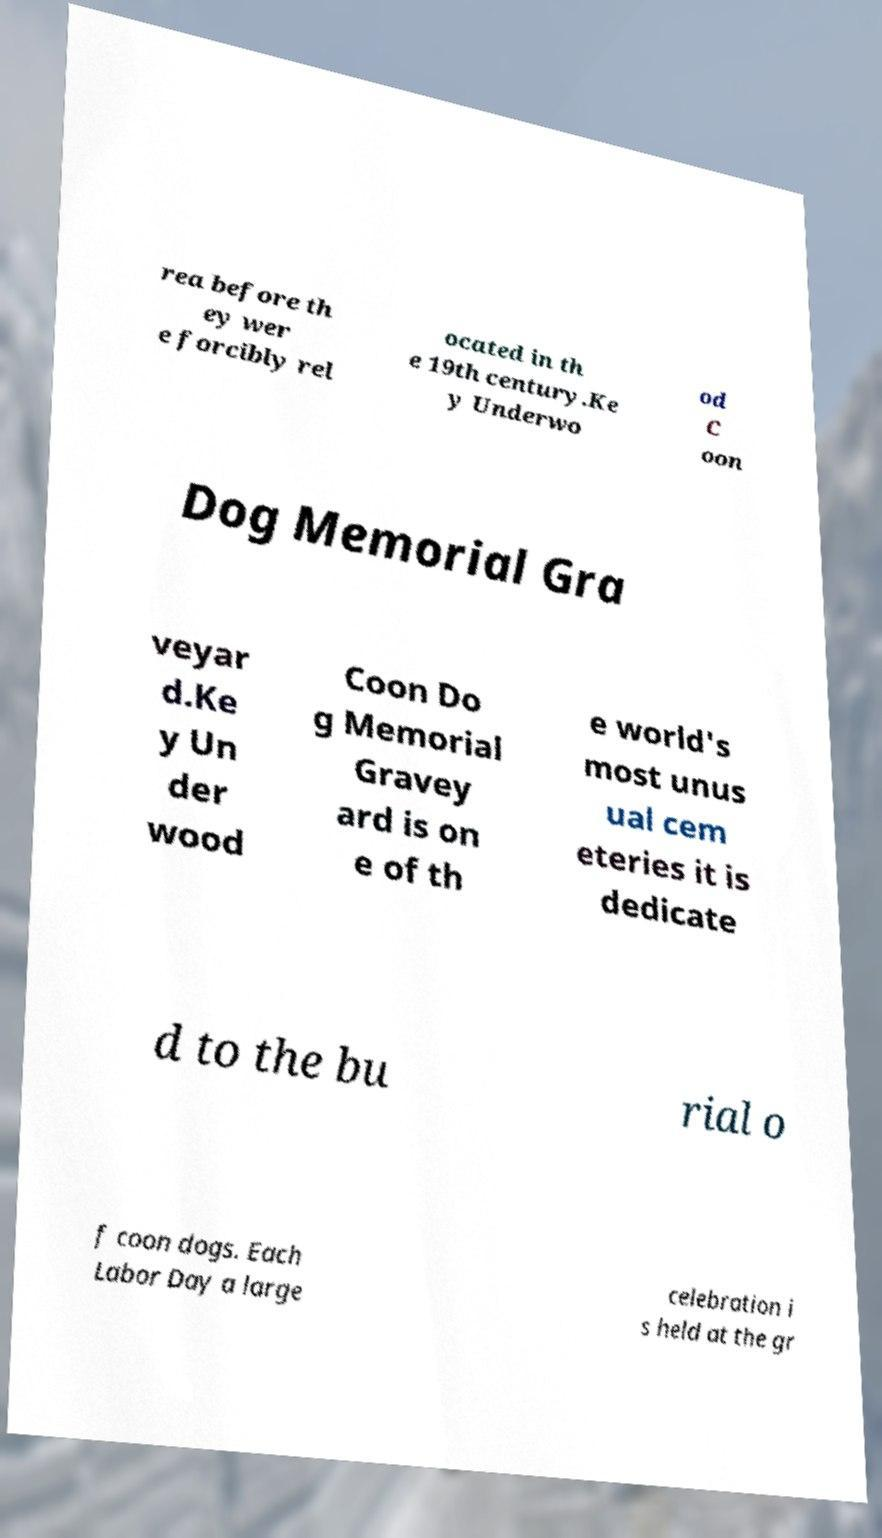Please identify and transcribe the text found in this image. rea before th ey wer e forcibly rel ocated in th e 19th century.Ke y Underwo od C oon Dog Memorial Gra veyar d.Ke y Un der wood Coon Do g Memorial Gravey ard is on e of th e world's most unus ual cem eteries it is dedicate d to the bu rial o f coon dogs. Each Labor Day a large celebration i s held at the gr 